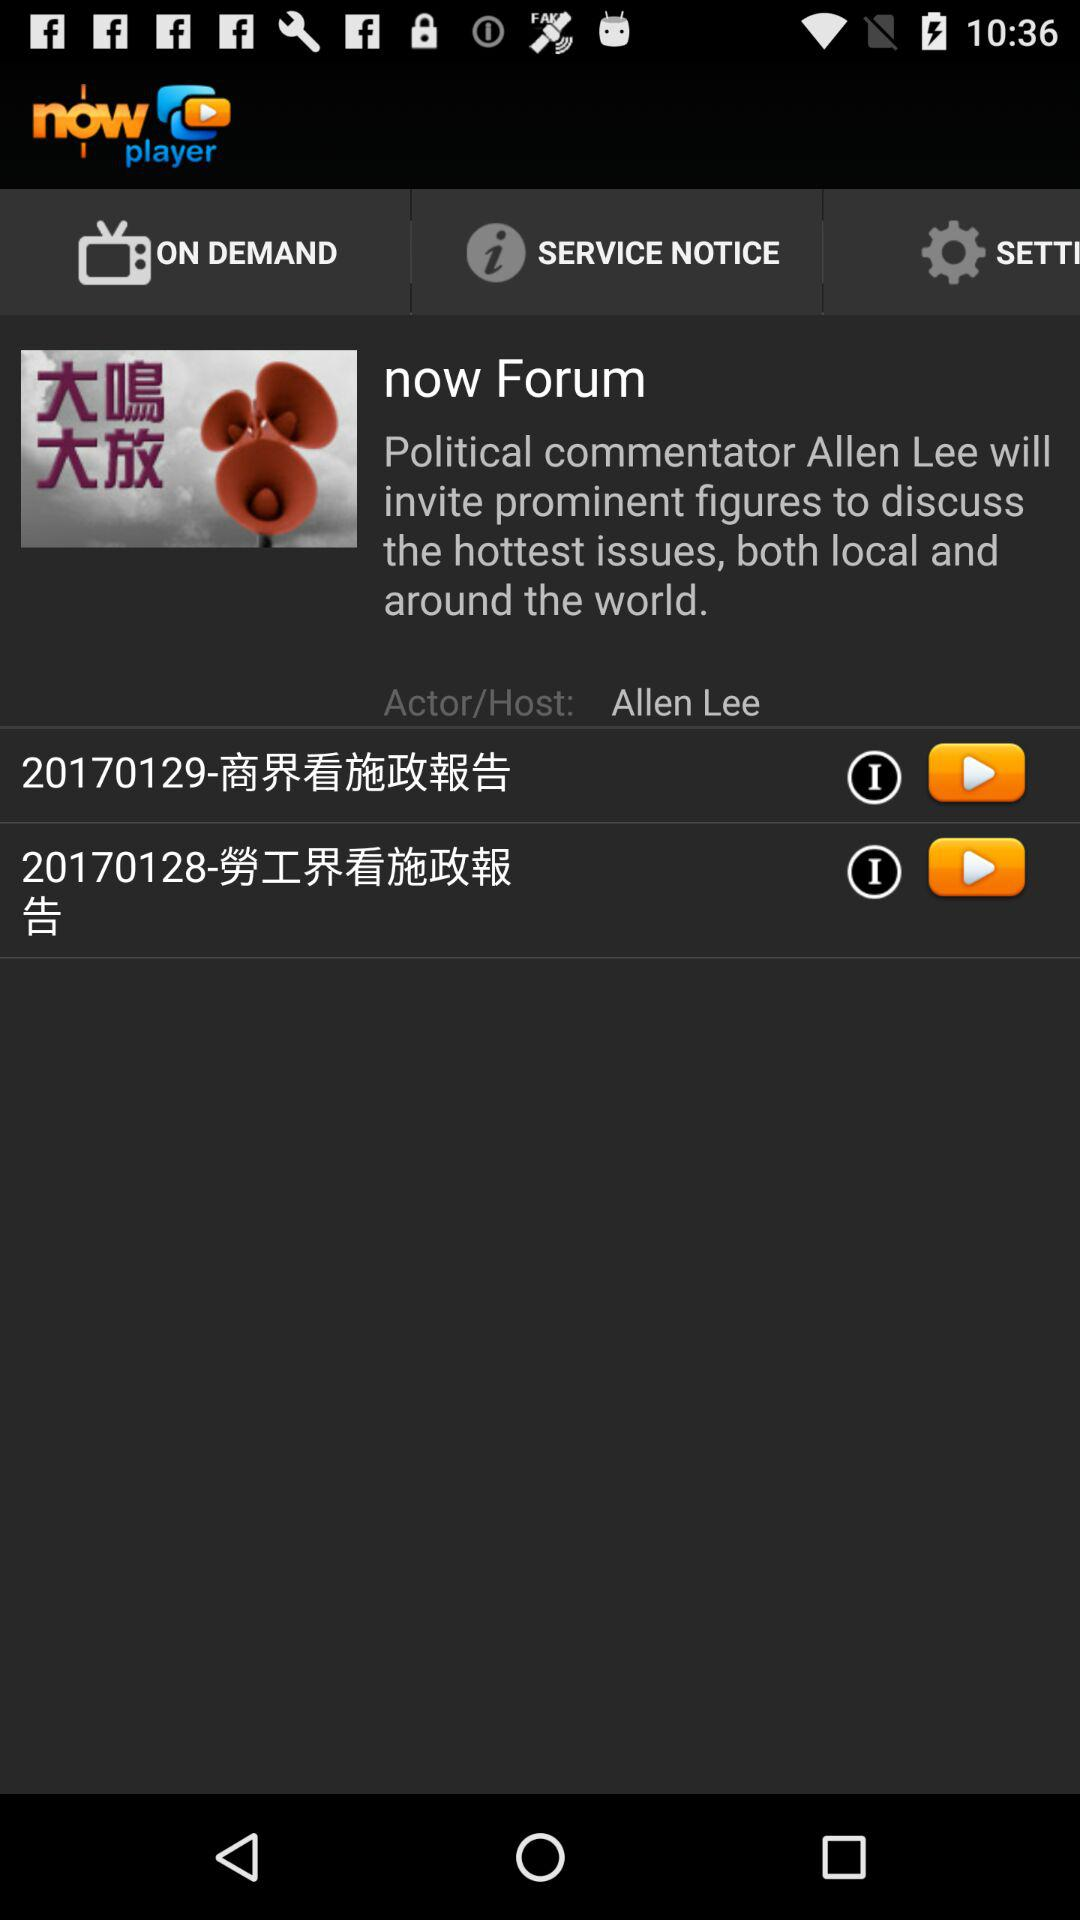What is the name of the application? The name of the application is "now player". 